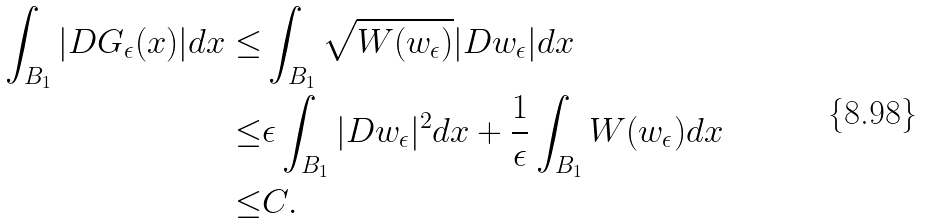Convert formula to latex. <formula><loc_0><loc_0><loc_500><loc_500>\int _ { B _ { 1 } } | D G _ { \epsilon } ( x ) | d x \leq & \int _ { B _ { 1 } } \sqrt { W ( w _ { \epsilon } ) } | D w _ { \epsilon } | d x \\ \leq & \epsilon \int _ { B _ { 1 } } | D w _ { \epsilon } | ^ { 2 } d x + \frac { 1 } { \epsilon } \int _ { B _ { 1 } } W ( w _ { \epsilon } ) d x \\ \leq & C .</formula> 